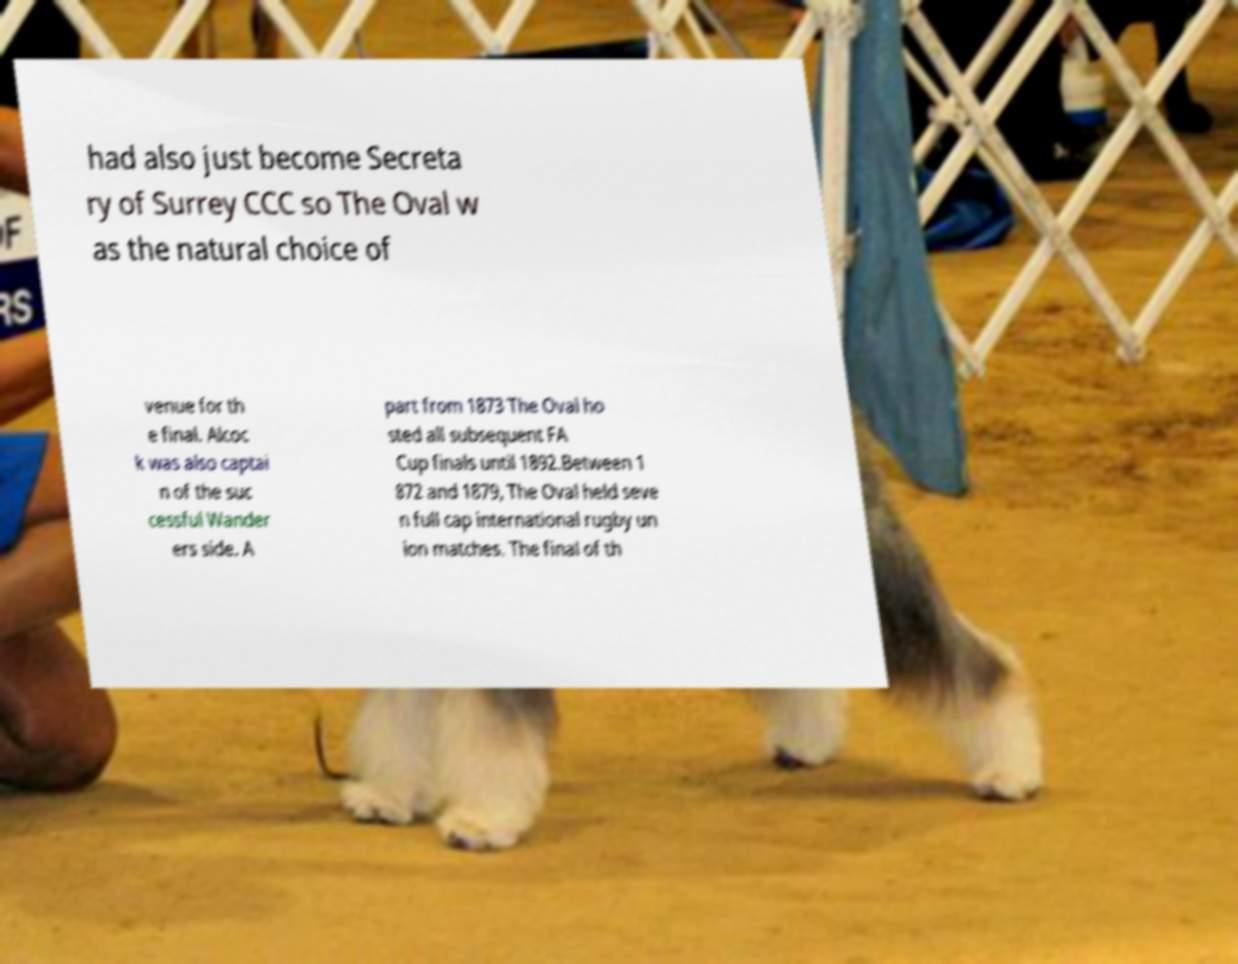There's text embedded in this image that I need extracted. Can you transcribe it verbatim? had also just become Secreta ry of Surrey CCC so The Oval w as the natural choice of venue for th e final. Alcoc k was also captai n of the suc cessful Wander ers side. A part from 1873 The Oval ho sted all subsequent FA Cup finals until 1892.Between 1 872 and 1879, The Oval held seve n full cap international rugby un ion matches. The final of th 